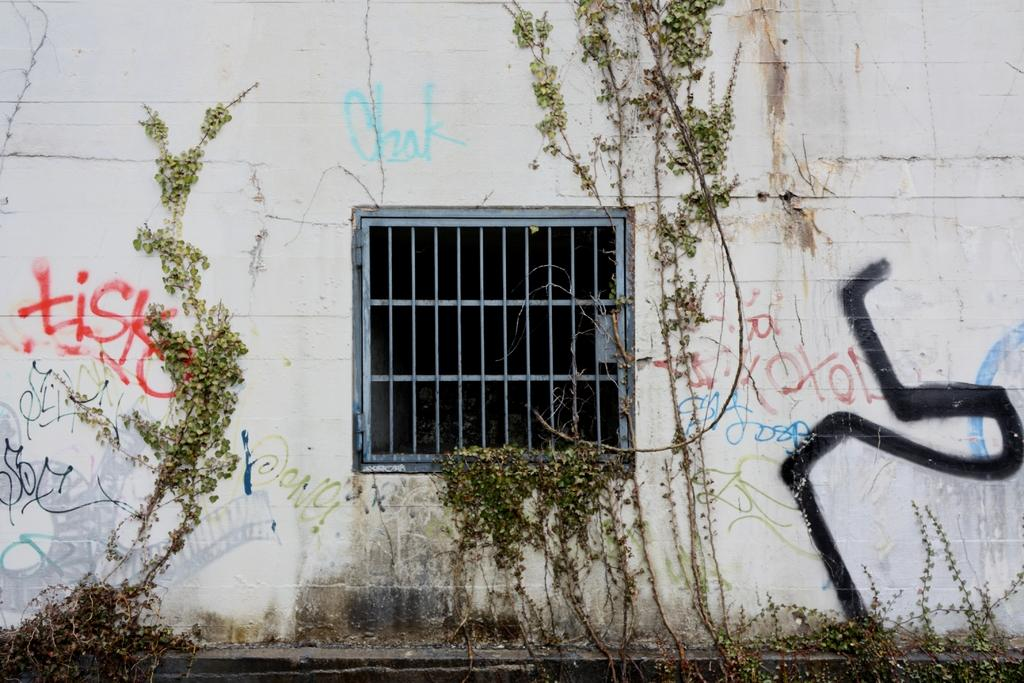What is on the wall in the image? There is a wall with text in the image, and creepers are present on the wall. What else can be seen on the wall? Creepers are present on the wall. Is there any opening in the wall? There is a window in the image. What type of clock is hanging on the wall in the image? There is no clock present in the image; it only features a wall with text and creepers, and a window. 